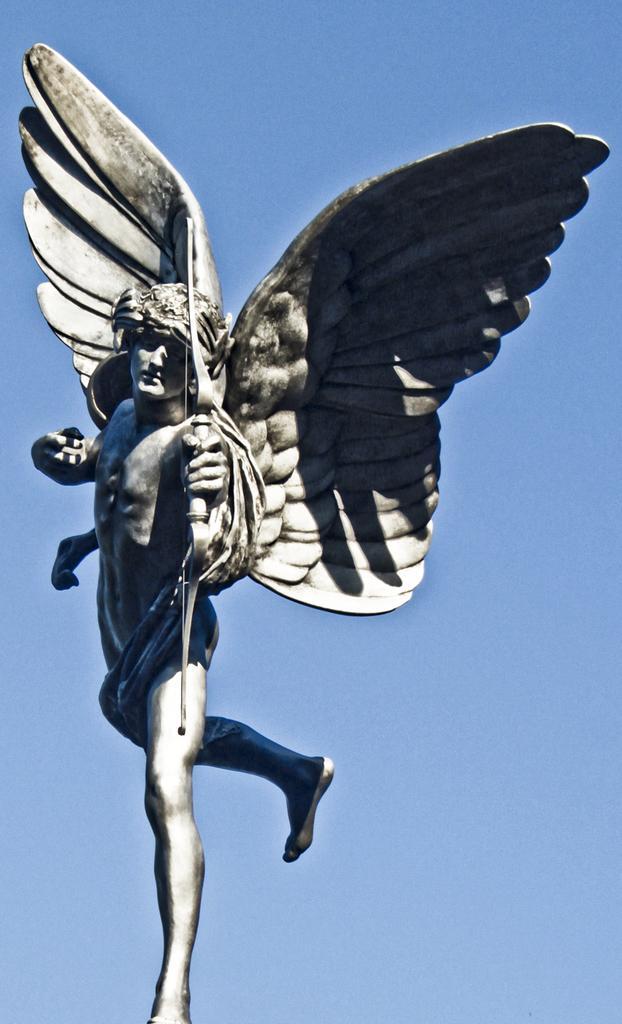Could you give a brief overview of what you see in this image? In this image we can see a statue which resembles like a fairy with wings and we can also see a arrow in hand. In the background, we can see the sky. 